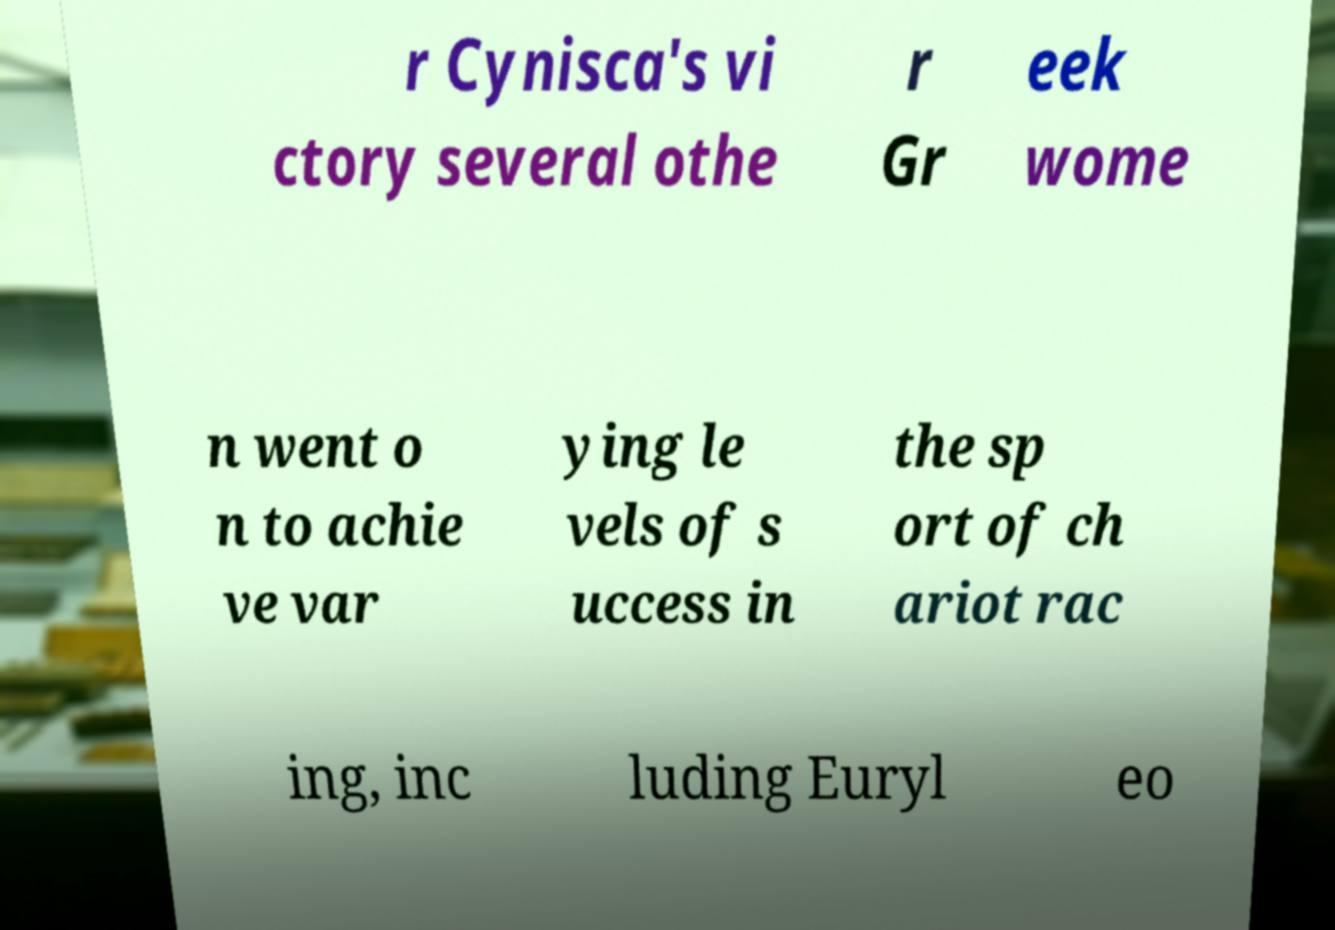Please read and relay the text visible in this image. What does it say? r Cynisca's vi ctory several othe r Gr eek wome n went o n to achie ve var ying le vels of s uccess in the sp ort of ch ariot rac ing, inc luding Euryl eo 